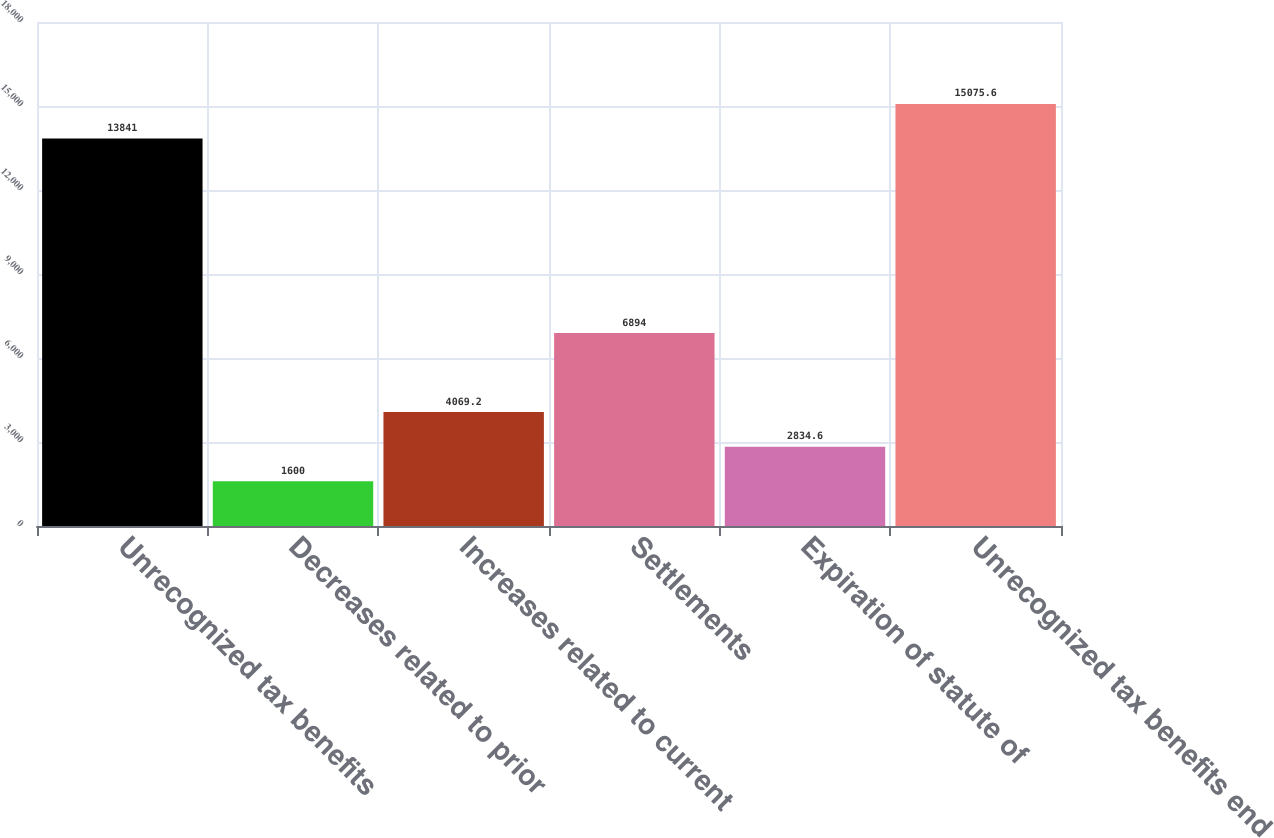Convert chart to OTSL. <chart><loc_0><loc_0><loc_500><loc_500><bar_chart><fcel>Unrecognized tax benefits<fcel>Decreases related to prior<fcel>Increases related to current<fcel>Settlements<fcel>Expiration of statute of<fcel>Unrecognized tax benefits end<nl><fcel>13841<fcel>1600<fcel>4069.2<fcel>6894<fcel>2834.6<fcel>15075.6<nl></chart> 